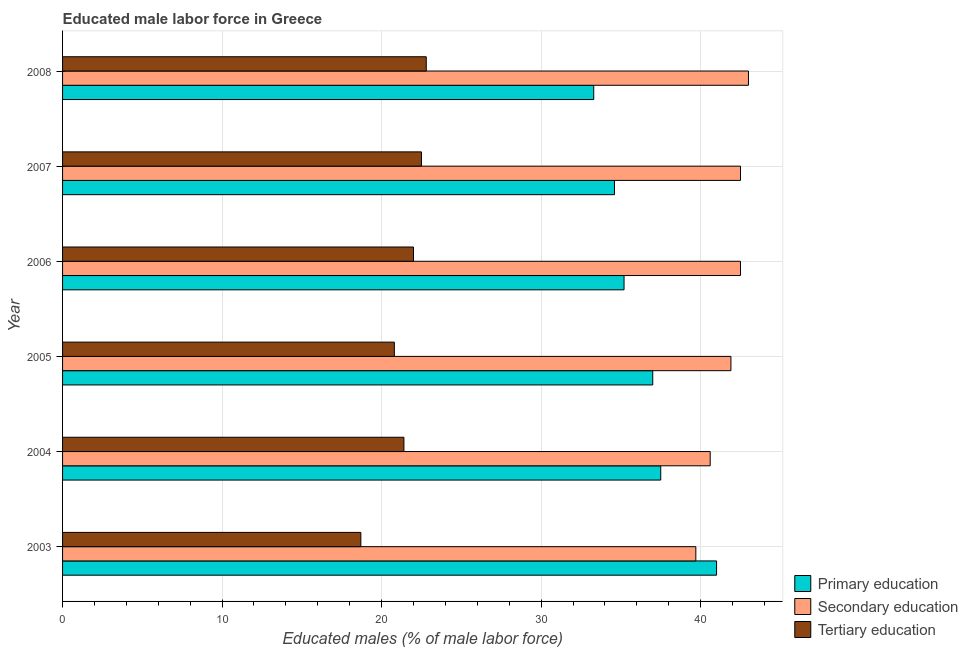How many groups of bars are there?
Make the answer very short. 6. Are the number of bars per tick equal to the number of legend labels?
Make the answer very short. Yes. How many bars are there on the 3rd tick from the top?
Your answer should be very brief. 3. In how many cases, is the number of bars for a given year not equal to the number of legend labels?
Offer a terse response. 0. What is the percentage of male labor force who received tertiary education in 2006?
Provide a short and direct response. 22. Across all years, what is the maximum percentage of male labor force who received primary education?
Make the answer very short. 41. Across all years, what is the minimum percentage of male labor force who received tertiary education?
Make the answer very short. 18.7. In which year was the percentage of male labor force who received secondary education maximum?
Provide a succinct answer. 2008. What is the total percentage of male labor force who received primary education in the graph?
Your answer should be very brief. 218.6. What is the difference between the percentage of male labor force who received tertiary education in 2007 and the percentage of male labor force who received secondary education in 2008?
Provide a short and direct response. -20.5. What is the average percentage of male labor force who received primary education per year?
Provide a succinct answer. 36.43. In the year 2003, what is the difference between the percentage of male labor force who received tertiary education and percentage of male labor force who received secondary education?
Your answer should be very brief. -21. In how many years, is the percentage of male labor force who received primary education greater than 26 %?
Your answer should be compact. 6. Is the difference between the percentage of male labor force who received secondary education in 2006 and 2007 greater than the difference between the percentage of male labor force who received primary education in 2006 and 2007?
Keep it short and to the point. No. What is the difference between the highest and the lowest percentage of male labor force who received secondary education?
Offer a very short reply. 3.3. In how many years, is the percentage of male labor force who received tertiary education greater than the average percentage of male labor force who received tertiary education taken over all years?
Your answer should be very brief. 4. What does the 2nd bar from the top in 2005 represents?
Your response must be concise. Secondary education. What does the 3rd bar from the bottom in 2008 represents?
Offer a terse response. Tertiary education. What is the difference between two consecutive major ticks on the X-axis?
Your answer should be very brief. 10. Does the graph contain any zero values?
Your response must be concise. No. Where does the legend appear in the graph?
Provide a short and direct response. Bottom right. How many legend labels are there?
Give a very brief answer. 3. How are the legend labels stacked?
Ensure brevity in your answer.  Vertical. What is the title of the graph?
Provide a succinct answer. Educated male labor force in Greece. Does "Labor Market" appear as one of the legend labels in the graph?
Offer a terse response. No. What is the label or title of the X-axis?
Offer a terse response. Educated males (% of male labor force). What is the label or title of the Y-axis?
Your answer should be very brief. Year. What is the Educated males (% of male labor force) of Primary education in 2003?
Provide a short and direct response. 41. What is the Educated males (% of male labor force) in Secondary education in 2003?
Make the answer very short. 39.7. What is the Educated males (% of male labor force) of Tertiary education in 2003?
Keep it short and to the point. 18.7. What is the Educated males (% of male labor force) of Primary education in 2004?
Make the answer very short. 37.5. What is the Educated males (% of male labor force) of Secondary education in 2004?
Offer a terse response. 40.6. What is the Educated males (% of male labor force) in Tertiary education in 2004?
Ensure brevity in your answer.  21.4. What is the Educated males (% of male labor force) of Primary education in 2005?
Provide a succinct answer. 37. What is the Educated males (% of male labor force) of Secondary education in 2005?
Your answer should be compact. 41.9. What is the Educated males (% of male labor force) in Tertiary education in 2005?
Keep it short and to the point. 20.8. What is the Educated males (% of male labor force) in Primary education in 2006?
Your response must be concise. 35.2. What is the Educated males (% of male labor force) in Secondary education in 2006?
Your answer should be compact. 42.5. What is the Educated males (% of male labor force) in Primary education in 2007?
Your response must be concise. 34.6. What is the Educated males (% of male labor force) in Secondary education in 2007?
Your response must be concise. 42.5. What is the Educated males (% of male labor force) of Primary education in 2008?
Offer a very short reply. 33.3. What is the Educated males (% of male labor force) in Secondary education in 2008?
Provide a short and direct response. 43. What is the Educated males (% of male labor force) in Tertiary education in 2008?
Offer a very short reply. 22.8. Across all years, what is the maximum Educated males (% of male labor force) in Tertiary education?
Keep it short and to the point. 22.8. Across all years, what is the minimum Educated males (% of male labor force) in Primary education?
Provide a succinct answer. 33.3. Across all years, what is the minimum Educated males (% of male labor force) of Secondary education?
Your answer should be very brief. 39.7. Across all years, what is the minimum Educated males (% of male labor force) of Tertiary education?
Offer a very short reply. 18.7. What is the total Educated males (% of male labor force) of Primary education in the graph?
Your response must be concise. 218.6. What is the total Educated males (% of male labor force) of Secondary education in the graph?
Your answer should be very brief. 250.2. What is the total Educated males (% of male labor force) of Tertiary education in the graph?
Your answer should be very brief. 128.2. What is the difference between the Educated males (% of male labor force) of Primary education in 2003 and that in 2004?
Your answer should be very brief. 3.5. What is the difference between the Educated males (% of male labor force) of Secondary education in 2003 and that in 2004?
Keep it short and to the point. -0.9. What is the difference between the Educated males (% of male labor force) in Primary education in 2003 and that in 2005?
Provide a succinct answer. 4. What is the difference between the Educated males (% of male labor force) of Tertiary education in 2003 and that in 2005?
Keep it short and to the point. -2.1. What is the difference between the Educated males (% of male labor force) of Secondary education in 2003 and that in 2006?
Give a very brief answer. -2.8. What is the difference between the Educated males (% of male labor force) of Tertiary education in 2003 and that in 2006?
Keep it short and to the point. -3.3. What is the difference between the Educated males (% of male labor force) of Primary education in 2003 and that in 2007?
Provide a short and direct response. 6.4. What is the difference between the Educated males (% of male labor force) in Secondary education in 2003 and that in 2007?
Offer a terse response. -2.8. What is the difference between the Educated males (% of male labor force) in Tertiary education in 2003 and that in 2007?
Provide a succinct answer. -3.8. What is the difference between the Educated males (% of male labor force) of Primary education in 2003 and that in 2008?
Make the answer very short. 7.7. What is the difference between the Educated males (% of male labor force) in Secondary education in 2003 and that in 2008?
Offer a terse response. -3.3. What is the difference between the Educated males (% of male labor force) of Tertiary education in 2004 and that in 2005?
Ensure brevity in your answer.  0.6. What is the difference between the Educated males (% of male labor force) in Primary education in 2004 and that in 2006?
Your response must be concise. 2.3. What is the difference between the Educated males (% of male labor force) of Primary education in 2004 and that in 2008?
Your answer should be compact. 4.2. What is the difference between the Educated males (% of male labor force) of Secondary education in 2004 and that in 2008?
Make the answer very short. -2.4. What is the difference between the Educated males (% of male labor force) in Tertiary education in 2004 and that in 2008?
Make the answer very short. -1.4. What is the difference between the Educated males (% of male labor force) in Primary education in 2005 and that in 2007?
Your answer should be compact. 2.4. What is the difference between the Educated males (% of male labor force) in Secondary education in 2005 and that in 2007?
Provide a succinct answer. -0.6. What is the difference between the Educated males (% of male labor force) of Tertiary education in 2005 and that in 2007?
Provide a succinct answer. -1.7. What is the difference between the Educated males (% of male labor force) of Secondary education in 2005 and that in 2008?
Your response must be concise. -1.1. What is the difference between the Educated males (% of male labor force) of Tertiary education in 2005 and that in 2008?
Keep it short and to the point. -2. What is the difference between the Educated males (% of male labor force) in Primary education in 2006 and that in 2007?
Give a very brief answer. 0.6. What is the difference between the Educated males (% of male labor force) in Secondary education in 2006 and that in 2007?
Provide a short and direct response. 0. What is the difference between the Educated males (% of male labor force) of Tertiary education in 2006 and that in 2007?
Offer a terse response. -0.5. What is the difference between the Educated males (% of male labor force) of Primary education in 2006 and that in 2008?
Your answer should be compact. 1.9. What is the difference between the Educated males (% of male labor force) in Secondary education in 2006 and that in 2008?
Your answer should be very brief. -0.5. What is the difference between the Educated males (% of male labor force) of Tertiary education in 2006 and that in 2008?
Provide a succinct answer. -0.8. What is the difference between the Educated males (% of male labor force) in Primary education in 2007 and that in 2008?
Your answer should be compact. 1.3. What is the difference between the Educated males (% of male labor force) of Primary education in 2003 and the Educated males (% of male labor force) of Secondary education in 2004?
Your answer should be compact. 0.4. What is the difference between the Educated males (% of male labor force) of Primary education in 2003 and the Educated males (% of male labor force) of Tertiary education in 2004?
Make the answer very short. 19.6. What is the difference between the Educated males (% of male labor force) in Secondary education in 2003 and the Educated males (% of male labor force) in Tertiary education in 2004?
Your answer should be very brief. 18.3. What is the difference between the Educated males (% of male labor force) of Primary education in 2003 and the Educated males (% of male labor force) of Secondary education in 2005?
Your answer should be compact. -0.9. What is the difference between the Educated males (% of male labor force) in Primary education in 2003 and the Educated males (% of male labor force) in Tertiary education in 2005?
Offer a terse response. 20.2. What is the difference between the Educated males (% of male labor force) in Secondary education in 2003 and the Educated males (% of male labor force) in Tertiary education in 2005?
Give a very brief answer. 18.9. What is the difference between the Educated males (% of male labor force) of Primary education in 2003 and the Educated males (% of male labor force) of Secondary education in 2006?
Your response must be concise. -1.5. What is the difference between the Educated males (% of male labor force) in Primary education in 2003 and the Educated males (% of male labor force) in Secondary education in 2007?
Keep it short and to the point. -1.5. What is the difference between the Educated males (% of male labor force) in Primary education in 2003 and the Educated males (% of male labor force) in Tertiary education in 2007?
Offer a terse response. 18.5. What is the difference between the Educated males (% of male labor force) of Secondary education in 2003 and the Educated males (% of male labor force) of Tertiary education in 2007?
Your answer should be very brief. 17.2. What is the difference between the Educated males (% of male labor force) in Primary education in 2003 and the Educated males (% of male labor force) in Secondary education in 2008?
Offer a very short reply. -2. What is the difference between the Educated males (% of male labor force) in Primary education in 2004 and the Educated males (% of male labor force) in Secondary education in 2005?
Ensure brevity in your answer.  -4.4. What is the difference between the Educated males (% of male labor force) in Primary education in 2004 and the Educated males (% of male labor force) in Tertiary education in 2005?
Provide a succinct answer. 16.7. What is the difference between the Educated males (% of male labor force) of Secondary education in 2004 and the Educated males (% of male labor force) of Tertiary education in 2005?
Ensure brevity in your answer.  19.8. What is the difference between the Educated males (% of male labor force) of Primary education in 2004 and the Educated males (% of male labor force) of Secondary education in 2006?
Provide a short and direct response. -5. What is the difference between the Educated males (% of male labor force) of Secondary education in 2004 and the Educated males (% of male labor force) of Tertiary education in 2006?
Provide a short and direct response. 18.6. What is the difference between the Educated males (% of male labor force) of Primary education in 2004 and the Educated males (% of male labor force) of Secondary education in 2007?
Make the answer very short. -5. What is the difference between the Educated males (% of male labor force) of Primary education in 2005 and the Educated males (% of male labor force) of Secondary education in 2006?
Make the answer very short. -5.5. What is the difference between the Educated males (% of male labor force) of Primary education in 2005 and the Educated males (% of male labor force) of Tertiary education in 2006?
Your answer should be very brief. 15. What is the difference between the Educated males (% of male labor force) of Secondary education in 2005 and the Educated males (% of male labor force) of Tertiary education in 2006?
Your response must be concise. 19.9. What is the difference between the Educated males (% of male labor force) in Primary education in 2005 and the Educated males (% of male labor force) in Secondary education in 2008?
Ensure brevity in your answer.  -6. What is the difference between the Educated males (% of male labor force) of Secondary education in 2006 and the Educated males (% of male labor force) of Tertiary education in 2007?
Provide a short and direct response. 20. What is the difference between the Educated males (% of male labor force) of Primary education in 2006 and the Educated males (% of male labor force) of Secondary education in 2008?
Provide a succinct answer. -7.8. What is the difference between the Educated males (% of male labor force) of Primary education in 2006 and the Educated males (% of male labor force) of Tertiary education in 2008?
Ensure brevity in your answer.  12.4. What is the difference between the Educated males (% of male labor force) in Primary education in 2007 and the Educated males (% of male labor force) in Tertiary education in 2008?
Ensure brevity in your answer.  11.8. What is the average Educated males (% of male labor force) of Primary education per year?
Provide a succinct answer. 36.43. What is the average Educated males (% of male labor force) in Secondary education per year?
Ensure brevity in your answer.  41.7. What is the average Educated males (% of male labor force) in Tertiary education per year?
Keep it short and to the point. 21.37. In the year 2003, what is the difference between the Educated males (% of male labor force) of Primary education and Educated males (% of male labor force) of Secondary education?
Make the answer very short. 1.3. In the year 2003, what is the difference between the Educated males (% of male labor force) of Primary education and Educated males (% of male labor force) of Tertiary education?
Offer a very short reply. 22.3. In the year 2004, what is the difference between the Educated males (% of male labor force) of Primary education and Educated males (% of male labor force) of Secondary education?
Provide a succinct answer. -3.1. In the year 2005, what is the difference between the Educated males (% of male labor force) in Primary education and Educated males (% of male labor force) in Secondary education?
Give a very brief answer. -4.9. In the year 2005, what is the difference between the Educated males (% of male labor force) in Secondary education and Educated males (% of male labor force) in Tertiary education?
Provide a succinct answer. 21.1. In the year 2006, what is the difference between the Educated males (% of male labor force) of Primary education and Educated males (% of male labor force) of Tertiary education?
Your answer should be compact. 13.2. In the year 2007, what is the difference between the Educated males (% of male labor force) of Primary education and Educated males (% of male labor force) of Secondary education?
Give a very brief answer. -7.9. In the year 2008, what is the difference between the Educated males (% of male labor force) of Primary education and Educated males (% of male labor force) of Secondary education?
Provide a short and direct response. -9.7. In the year 2008, what is the difference between the Educated males (% of male labor force) of Primary education and Educated males (% of male labor force) of Tertiary education?
Your answer should be very brief. 10.5. In the year 2008, what is the difference between the Educated males (% of male labor force) of Secondary education and Educated males (% of male labor force) of Tertiary education?
Your answer should be compact. 20.2. What is the ratio of the Educated males (% of male labor force) in Primary education in 2003 to that in 2004?
Your answer should be compact. 1.09. What is the ratio of the Educated males (% of male labor force) of Secondary education in 2003 to that in 2004?
Provide a short and direct response. 0.98. What is the ratio of the Educated males (% of male labor force) of Tertiary education in 2003 to that in 2004?
Provide a succinct answer. 0.87. What is the ratio of the Educated males (% of male labor force) in Primary education in 2003 to that in 2005?
Give a very brief answer. 1.11. What is the ratio of the Educated males (% of male labor force) of Secondary education in 2003 to that in 2005?
Provide a succinct answer. 0.95. What is the ratio of the Educated males (% of male labor force) of Tertiary education in 2003 to that in 2005?
Your answer should be compact. 0.9. What is the ratio of the Educated males (% of male labor force) of Primary education in 2003 to that in 2006?
Make the answer very short. 1.16. What is the ratio of the Educated males (% of male labor force) in Secondary education in 2003 to that in 2006?
Give a very brief answer. 0.93. What is the ratio of the Educated males (% of male labor force) of Tertiary education in 2003 to that in 2006?
Your answer should be very brief. 0.85. What is the ratio of the Educated males (% of male labor force) of Primary education in 2003 to that in 2007?
Give a very brief answer. 1.19. What is the ratio of the Educated males (% of male labor force) of Secondary education in 2003 to that in 2007?
Keep it short and to the point. 0.93. What is the ratio of the Educated males (% of male labor force) in Tertiary education in 2003 to that in 2007?
Your answer should be very brief. 0.83. What is the ratio of the Educated males (% of male labor force) in Primary education in 2003 to that in 2008?
Your answer should be very brief. 1.23. What is the ratio of the Educated males (% of male labor force) in Secondary education in 2003 to that in 2008?
Provide a succinct answer. 0.92. What is the ratio of the Educated males (% of male labor force) in Tertiary education in 2003 to that in 2008?
Offer a terse response. 0.82. What is the ratio of the Educated males (% of male labor force) of Primary education in 2004 to that in 2005?
Your answer should be very brief. 1.01. What is the ratio of the Educated males (% of male labor force) in Secondary education in 2004 to that in 2005?
Your answer should be compact. 0.97. What is the ratio of the Educated males (% of male labor force) in Tertiary education in 2004 to that in 2005?
Provide a succinct answer. 1.03. What is the ratio of the Educated males (% of male labor force) in Primary education in 2004 to that in 2006?
Provide a succinct answer. 1.07. What is the ratio of the Educated males (% of male labor force) of Secondary education in 2004 to that in 2006?
Offer a very short reply. 0.96. What is the ratio of the Educated males (% of male labor force) in Tertiary education in 2004 to that in 2006?
Make the answer very short. 0.97. What is the ratio of the Educated males (% of male labor force) of Primary education in 2004 to that in 2007?
Ensure brevity in your answer.  1.08. What is the ratio of the Educated males (% of male labor force) of Secondary education in 2004 to that in 2007?
Offer a very short reply. 0.96. What is the ratio of the Educated males (% of male labor force) of Tertiary education in 2004 to that in 2007?
Your answer should be compact. 0.95. What is the ratio of the Educated males (% of male labor force) of Primary education in 2004 to that in 2008?
Offer a very short reply. 1.13. What is the ratio of the Educated males (% of male labor force) of Secondary education in 2004 to that in 2008?
Ensure brevity in your answer.  0.94. What is the ratio of the Educated males (% of male labor force) in Tertiary education in 2004 to that in 2008?
Keep it short and to the point. 0.94. What is the ratio of the Educated males (% of male labor force) in Primary education in 2005 to that in 2006?
Keep it short and to the point. 1.05. What is the ratio of the Educated males (% of male labor force) of Secondary education in 2005 to that in 2006?
Make the answer very short. 0.99. What is the ratio of the Educated males (% of male labor force) of Tertiary education in 2005 to that in 2006?
Your answer should be very brief. 0.95. What is the ratio of the Educated males (% of male labor force) in Primary education in 2005 to that in 2007?
Your answer should be compact. 1.07. What is the ratio of the Educated males (% of male labor force) in Secondary education in 2005 to that in 2007?
Keep it short and to the point. 0.99. What is the ratio of the Educated males (% of male labor force) of Tertiary education in 2005 to that in 2007?
Make the answer very short. 0.92. What is the ratio of the Educated males (% of male labor force) of Secondary education in 2005 to that in 2008?
Your answer should be compact. 0.97. What is the ratio of the Educated males (% of male labor force) in Tertiary education in 2005 to that in 2008?
Ensure brevity in your answer.  0.91. What is the ratio of the Educated males (% of male labor force) in Primary education in 2006 to that in 2007?
Offer a very short reply. 1.02. What is the ratio of the Educated males (% of male labor force) in Secondary education in 2006 to that in 2007?
Your answer should be compact. 1. What is the ratio of the Educated males (% of male labor force) of Tertiary education in 2006 to that in 2007?
Your answer should be compact. 0.98. What is the ratio of the Educated males (% of male labor force) in Primary education in 2006 to that in 2008?
Your answer should be compact. 1.06. What is the ratio of the Educated males (% of male labor force) in Secondary education in 2006 to that in 2008?
Keep it short and to the point. 0.99. What is the ratio of the Educated males (% of male labor force) in Tertiary education in 2006 to that in 2008?
Ensure brevity in your answer.  0.96. What is the ratio of the Educated males (% of male labor force) in Primary education in 2007 to that in 2008?
Offer a terse response. 1.04. What is the ratio of the Educated males (% of male labor force) in Secondary education in 2007 to that in 2008?
Offer a terse response. 0.99. What is the ratio of the Educated males (% of male labor force) of Tertiary education in 2007 to that in 2008?
Your answer should be compact. 0.99. What is the difference between the highest and the second highest Educated males (% of male labor force) of Primary education?
Make the answer very short. 3.5. 